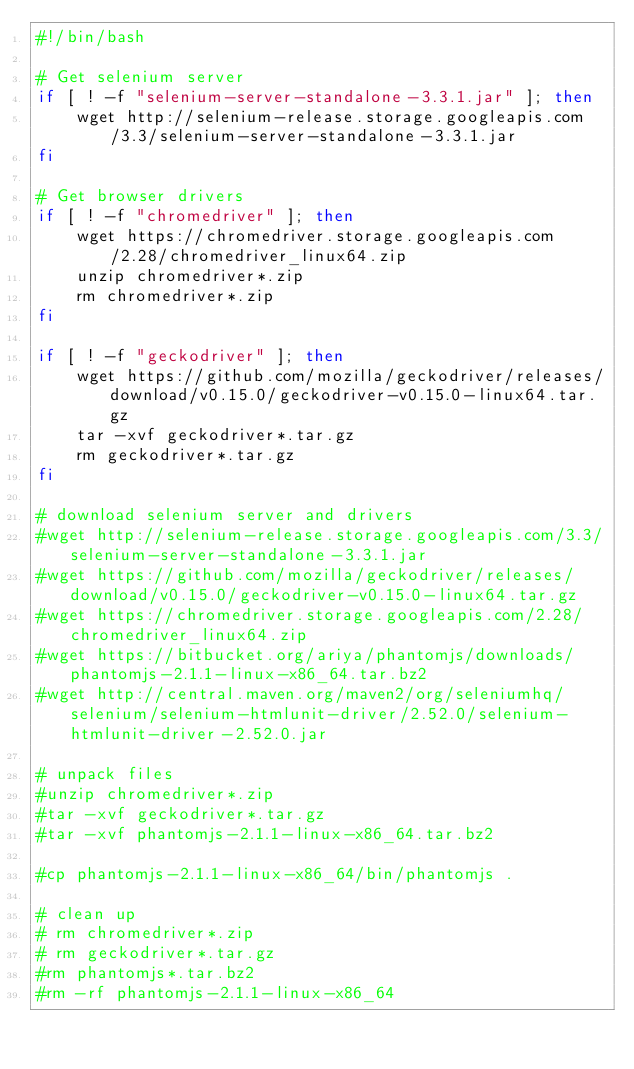<code> <loc_0><loc_0><loc_500><loc_500><_Bash_>#!/bin/bash

# Get selenium server
if [ ! -f "selenium-server-standalone-3.3.1.jar" ]; then
    wget http://selenium-release.storage.googleapis.com/3.3/selenium-server-standalone-3.3.1.jar
fi

# Get browser drivers
if [ ! -f "chromedriver" ]; then
    wget https://chromedriver.storage.googleapis.com/2.28/chromedriver_linux64.zip
    unzip chromedriver*.zip
    rm chromedriver*.zip
fi

if [ ! -f "geckodriver" ]; then
    wget https://github.com/mozilla/geckodriver/releases/download/v0.15.0/geckodriver-v0.15.0-linux64.tar.gz
    tar -xvf geckodriver*.tar.gz
    rm geckodriver*.tar.gz
fi

# download selenium server and drivers
#wget http://selenium-release.storage.googleapis.com/3.3/selenium-server-standalone-3.3.1.jar
#wget https://github.com/mozilla/geckodriver/releases/download/v0.15.0/geckodriver-v0.15.0-linux64.tar.gz
#wget https://chromedriver.storage.googleapis.com/2.28/chromedriver_linux64.zip
#wget https://bitbucket.org/ariya/phantomjs/downloads/phantomjs-2.1.1-linux-x86_64.tar.bz2
#wget http://central.maven.org/maven2/org/seleniumhq/selenium/selenium-htmlunit-driver/2.52.0/selenium-htmlunit-driver-2.52.0.jar

# unpack files
#unzip chromedriver*.zip
#tar -xvf geckodriver*.tar.gz
#tar -xvf phantomjs-2.1.1-linux-x86_64.tar.bz2

#cp phantomjs-2.1.1-linux-x86_64/bin/phantomjs .

# clean up
# rm chromedriver*.zip
# rm geckodriver*.tar.gz
#rm phantomjs*.tar.bz2
#rm -rf phantomjs-2.1.1-linux-x86_64
</code> 